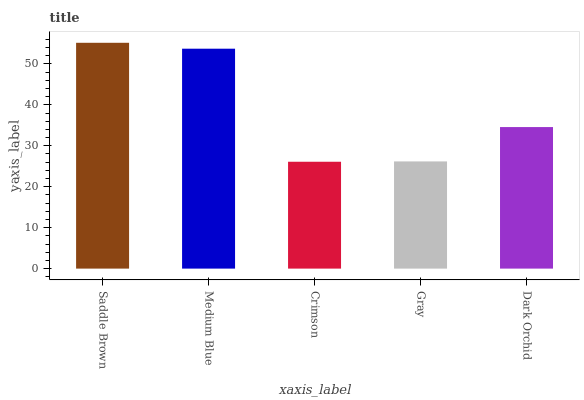Is Crimson the minimum?
Answer yes or no. Yes. Is Saddle Brown the maximum?
Answer yes or no. Yes. Is Medium Blue the minimum?
Answer yes or no. No. Is Medium Blue the maximum?
Answer yes or no. No. Is Saddle Brown greater than Medium Blue?
Answer yes or no. Yes. Is Medium Blue less than Saddle Brown?
Answer yes or no. Yes. Is Medium Blue greater than Saddle Brown?
Answer yes or no. No. Is Saddle Brown less than Medium Blue?
Answer yes or no. No. Is Dark Orchid the high median?
Answer yes or no. Yes. Is Dark Orchid the low median?
Answer yes or no. Yes. Is Saddle Brown the high median?
Answer yes or no. No. Is Crimson the low median?
Answer yes or no. No. 